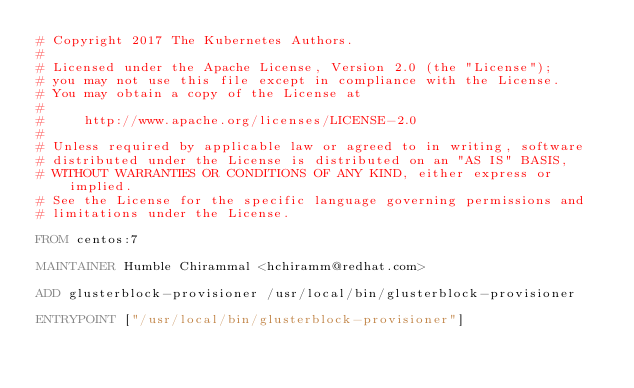<code> <loc_0><loc_0><loc_500><loc_500><_Dockerfile_># Copyright 2017 The Kubernetes Authors.
#
# Licensed under the Apache License, Version 2.0 (the "License");
# you may not use this file except in compliance with the License.
# You may obtain a copy of the License at
#
#     http://www.apache.org/licenses/LICENSE-2.0
#
# Unless required by applicable law or agreed to in writing, software
# distributed under the License is distributed on an "AS IS" BASIS,
# WITHOUT WARRANTIES OR CONDITIONS OF ANY KIND, either express or implied.
# See the License for the specific language governing permissions and
# limitations under the License.

FROM centos:7

MAINTAINER Humble Chirammal <hchiramm@redhat.com>

ADD glusterblock-provisioner /usr/local/bin/glusterblock-provisioner

ENTRYPOINT ["/usr/local/bin/glusterblock-provisioner"] 
</code> 